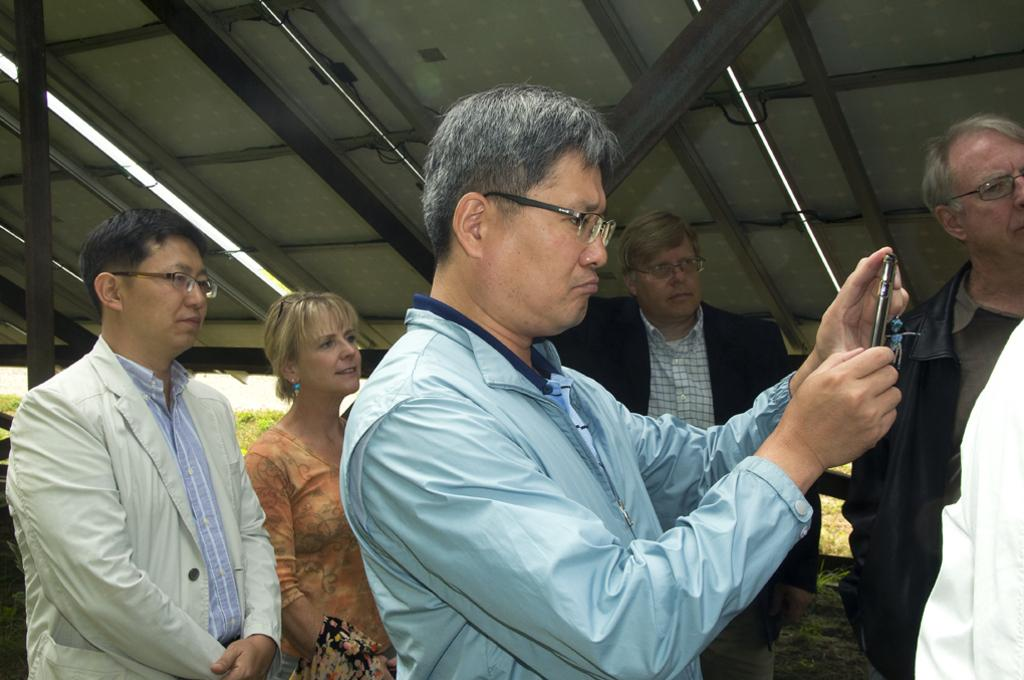What are the people in the image doing? The people in the image are standing. Can you describe any specific object that one of the people is holding? Yes, there is a person holding a mobile phone in his hand. What type of lighting is visible in the image? There are tube lights visible in the image. How many knots are tied on the bag in the image? There is no bag or knots present in the image. What fact can be learned about the person holding the mobile phone in the image? The provided facts do not include any additional information about the person holding the mobile phone, so we cannot determine any specific fact about him. 